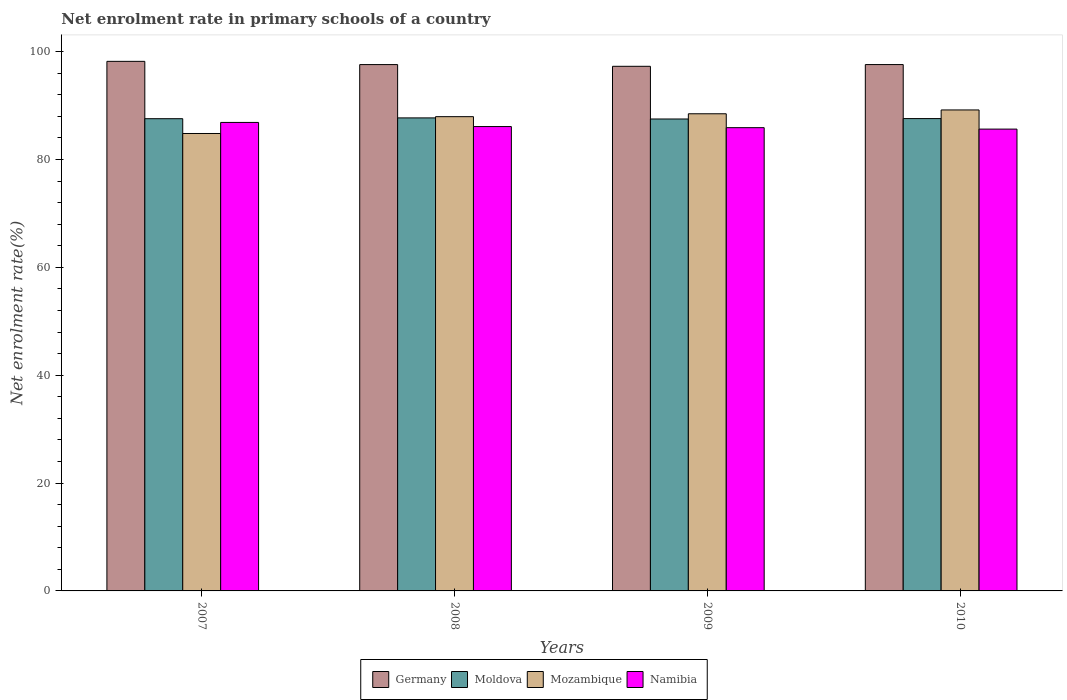How many groups of bars are there?
Provide a short and direct response. 4. Are the number of bars on each tick of the X-axis equal?
Provide a succinct answer. Yes. How many bars are there on the 2nd tick from the left?
Offer a terse response. 4. What is the label of the 1st group of bars from the left?
Give a very brief answer. 2007. What is the net enrolment rate in primary schools in Germany in 2008?
Provide a succinct answer. 97.6. Across all years, what is the maximum net enrolment rate in primary schools in Namibia?
Your answer should be compact. 86.88. Across all years, what is the minimum net enrolment rate in primary schools in Germany?
Provide a succinct answer. 97.29. In which year was the net enrolment rate in primary schools in Germany maximum?
Provide a short and direct response. 2007. In which year was the net enrolment rate in primary schools in Mozambique minimum?
Your answer should be very brief. 2007. What is the total net enrolment rate in primary schools in Mozambique in the graph?
Keep it short and to the point. 350.45. What is the difference between the net enrolment rate in primary schools in Namibia in 2008 and that in 2010?
Offer a terse response. 0.47. What is the difference between the net enrolment rate in primary schools in Namibia in 2008 and the net enrolment rate in primary schools in Mozambique in 2010?
Keep it short and to the point. -3.08. What is the average net enrolment rate in primary schools in Germany per year?
Give a very brief answer. 97.68. In the year 2009, what is the difference between the net enrolment rate in primary schools in Mozambique and net enrolment rate in primary schools in Namibia?
Provide a short and direct response. 2.57. What is the ratio of the net enrolment rate in primary schools in Moldova in 2008 to that in 2009?
Provide a short and direct response. 1. Is the difference between the net enrolment rate in primary schools in Mozambique in 2007 and 2010 greater than the difference between the net enrolment rate in primary schools in Namibia in 2007 and 2010?
Ensure brevity in your answer.  No. What is the difference between the highest and the second highest net enrolment rate in primary schools in Mozambique?
Make the answer very short. 0.71. What is the difference between the highest and the lowest net enrolment rate in primary schools in Moldova?
Keep it short and to the point. 0.2. In how many years, is the net enrolment rate in primary schools in Namibia greater than the average net enrolment rate in primary schools in Namibia taken over all years?
Provide a succinct answer. 1. Is it the case that in every year, the sum of the net enrolment rate in primary schools in Germany and net enrolment rate in primary schools in Namibia is greater than the sum of net enrolment rate in primary schools in Moldova and net enrolment rate in primary schools in Mozambique?
Provide a succinct answer. Yes. What does the 4th bar from the left in 2007 represents?
Provide a short and direct response. Namibia. What does the 2nd bar from the right in 2010 represents?
Provide a succinct answer. Mozambique. How many bars are there?
Give a very brief answer. 16. Are all the bars in the graph horizontal?
Offer a terse response. No. How many years are there in the graph?
Your answer should be compact. 4. What is the difference between two consecutive major ticks on the Y-axis?
Your response must be concise. 20. Are the values on the major ticks of Y-axis written in scientific E-notation?
Ensure brevity in your answer.  No. Does the graph contain any zero values?
Provide a short and direct response. No. Does the graph contain grids?
Offer a very short reply. No. What is the title of the graph?
Give a very brief answer. Net enrolment rate in primary schools of a country. What is the label or title of the X-axis?
Offer a very short reply. Years. What is the label or title of the Y-axis?
Offer a very short reply. Net enrolment rate(%). What is the Net enrolment rate(%) of Germany in 2007?
Your answer should be very brief. 98.2. What is the Net enrolment rate(%) of Moldova in 2007?
Provide a succinct answer. 87.57. What is the Net enrolment rate(%) in Mozambique in 2007?
Ensure brevity in your answer.  84.83. What is the Net enrolment rate(%) of Namibia in 2007?
Your answer should be compact. 86.88. What is the Net enrolment rate(%) of Germany in 2008?
Provide a succinct answer. 97.6. What is the Net enrolment rate(%) of Moldova in 2008?
Give a very brief answer. 87.72. What is the Net enrolment rate(%) in Mozambique in 2008?
Give a very brief answer. 87.95. What is the Net enrolment rate(%) of Namibia in 2008?
Provide a short and direct response. 86.11. What is the Net enrolment rate(%) of Germany in 2009?
Make the answer very short. 97.29. What is the Net enrolment rate(%) in Moldova in 2009?
Make the answer very short. 87.52. What is the Net enrolment rate(%) of Mozambique in 2009?
Offer a very short reply. 88.48. What is the Net enrolment rate(%) of Namibia in 2009?
Your answer should be very brief. 85.91. What is the Net enrolment rate(%) of Germany in 2010?
Your response must be concise. 97.61. What is the Net enrolment rate(%) in Moldova in 2010?
Keep it short and to the point. 87.59. What is the Net enrolment rate(%) of Mozambique in 2010?
Your answer should be compact. 89.19. What is the Net enrolment rate(%) in Namibia in 2010?
Provide a succinct answer. 85.64. Across all years, what is the maximum Net enrolment rate(%) of Germany?
Provide a succinct answer. 98.2. Across all years, what is the maximum Net enrolment rate(%) in Moldova?
Ensure brevity in your answer.  87.72. Across all years, what is the maximum Net enrolment rate(%) in Mozambique?
Your response must be concise. 89.19. Across all years, what is the maximum Net enrolment rate(%) in Namibia?
Provide a short and direct response. 86.88. Across all years, what is the minimum Net enrolment rate(%) in Germany?
Offer a terse response. 97.29. Across all years, what is the minimum Net enrolment rate(%) in Moldova?
Give a very brief answer. 87.52. Across all years, what is the minimum Net enrolment rate(%) in Mozambique?
Ensure brevity in your answer.  84.83. Across all years, what is the minimum Net enrolment rate(%) of Namibia?
Ensure brevity in your answer.  85.64. What is the total Net enrolment rate(%) in Germany in the graph?
Your answer should be very brief. 390.7. What is the total Net enrolment rate(%) of Moldova in the graph?
Give a very brief answer. 350.4. What is the total Net enrolment rate(%) in Mozambique in the graph?
Provide a succinct answer. 350.45. What is the total Net enrolment rate(%) in Namibia in the graph?
Ensure brevity in your answer.  344.54. What is the difference between the Net enrolment rate(%) in Germany in 2007 and that in 2008?
Your answer should be very brief. 0.6. What is the difference between the Net enrolment rate(%) of Moldova in 2007 and that in 2008?
Keep it short and to the point. -0.15. What is the difference between the Net enrolment rate(%) of Mozambique in 2007 and that in 2008?
Your response must be concise. -3.12. What is the difference between the Net enrolment rate(%) of Namibia in 2007 and that in 2008?
Make the answer very short. 0.77. What is the difference between the Net enrolment rate(%) in Germany in 2007 and that in 2009?
Keep it short and to the point. 0.92. What is the difference between the Net enrolment rate(%) in Moldova in 2007 and that in 2009?
Ensure brevity in your answer.  0.06. What is the difference between the Net enrolment rate(%) in Mozambique in 2007 and that in 2009?
Provide a short and direct response. -3.66. What is the difference between the Net enrolment rate(%) of Namibia in 2007 and that in 2009?
Your answer should be compact. 0.97. What is the difference between the Net enrolment rate(%) in Germany in 2007 and that in 2010?
Provide a succinct answer. 0.6. What is the difference between the Net enrolment rate(%) of Moldova in 2007 and that in 2010?
Your answer should be compact. -0.02. What is the difference between the Net enrolment rate(%) of Mozambique in 2007 and that in 2010?
Make the answer very short. -4.37. What is the difference between the Net enrolment rate(%) of Namibia in 2007 and that in 2010?
Make the answer very short. 1.24. What is the difference between the Net enrolment rate(%) in Germany in 2008 and that in 2009?
Give a very brief answer. 0.32. What is the difference between the Net enrolment rate(%) in Moldova in 2008 and that in 2009?
Offer a terse response. 0.2. What is the difference between the Net enrolment rate(%) of Mozambique in 2008 and that in 2009?
Offer a very short reply. -0.54. What is the difference between the Net enrolment rate(%) in Namibia in 2008 and that in 2009?
Your answer should be very brief. 0.2. What is the difference between the Net enrolment rate(%) in Germany in 2008 and that in 2010?
Keep it short and to the point. -0. What is the difference between the Net enrolment rate(%) of Moldova in 2008 and that in 2010?
Provide a succinct answer. 0.13. What is the difference between the Net enrolment rate(%) of Mozambique in 2008 and that in 2010?
Give a very brief answer. -1.25. What is the difference between the Net enrolment rate(%) of Namibia in 2008 and that in 2010?
Your answer should be very brief. 0.47. What is the difference between the Net enrolment rate(%) in Germany in 2009 and that in 2010?
Offer a terse response. -0.32. What is the difference between the Net enrolment rate(%) of Moldova in 2009 and that in 2010?
Keep it short and to the point. -0.08. What is the difference between the Net enrolment rate(%) in Mozambique in 2009 and that in 2010?
Offer a very short reply. -0.71. What is the difference between the Net enrolment rate(%) in Namibia in 2009 and that in 2010?
Your answer should be very brief. 0.27. What is the difference between the Net enrolment rate(%) of Germany in 2007 and the Net enrolment rate(%) of Moldova in 2008?
Provide a succinct answer. 10.49. What is the difference between the Net enrolment rate(%) in Germany in 2007 and the Net enrolment rate(%) in Mozambique in 2008?
Make the answer very short. 10.26. What is the difference between the Net enrolment rate(%) in Germany in 2007 and the Net enrolment rate(%) in Namibia in 2008?
Your response must be concise. 12.09. What is the difference between the Net enrolment rate(%) in Moldova in 2007 and the Net enrolment rate(%) in Mozambique in 2008?
Make the answer very short. -0.38. What is the difference between the Net enrolment rate(%) in Moldova in 2007 and the Net enrolment rate(%) in Namibia in 2008?
Your response must be concise. 1.46. What is the difference between the Net enrolment rate(%) of Mozambique in 2007 and the Net enrolment rate(%) of Namibia in 2008?
Give a very brief answer. -1.29. What is the difference between the Net enrolment rate(%) in Germany in 2007 and the Net enrolment rate(%) in Moldova in 2009?
Offer a very short reply. 10.69. What is the difference between the Net enrolment rate(%) of Germany in 2007 and the Net enrolment rate(%) of Mozambique in 2009?
Your response must be concise. 9.72. What is the difference between the Net enrolment rate(%) in Germany in 2007 and the Net enrolment rate(%) in Namibia in 2009?
Provide a short and direct response. 12.3. What is the difference between the Net enrolment rate(%) in Moldova in 2007 and the Net enrolment rate(%) in Mozambique in 2009?
Provide a succinct answer. -0.91. What is the difference between the Net enrolment rate(%) in Moldova in 2007 and the Net enrolment rate(%) in Namibia in 2009?
Provide a succinct answer. 1.66. What is the difference between the Net enrolment rate(%) of Mozambique in 2007 and the Net enrolment rate(%) of Namibia in 2009?
Your response must be concise. -1.08. What is the difference between the Net enrolment rate(%) in Germany in 2007 and the Net enrolment rate(%) in Moldova in 2010?
Your answer should be compact. 10.61. What is the difference between the Net enrolment rate(%) of Germany in 2007 and the Net enrolment rate(%) of Mozambique in 2010?
Make the answer very short. 9.01. What is the difference between the Net enrolment rate(%) in Germany in 2007 and the Net enrolment rate(%) in Namibia in 2010?
Your answer should be compact. 12.56. What is the difference between the Net enrolment rate(%) of Moldova in 2007 and the Net enrolment rate(%) of Mozambique in 2010?
Ensure brevity in your answer.  -1.62. What is the difference between the Net enrolment rate(%) of Moldova in 2007 and the Net enrolment rate(%) of Namibia in 2010?
Your answer should be very brief. 1.93. What is the difference between the Net enrolment rate(%) in Mozambique in 2007 and the Net enrolment rate(%) in Namibia in 2010?
Make the answer very short. -0.82. What is the difference between the Net enrolment rate(%) of Germany in 2008 and the Net enrolment rate(%) of Moldova in 2009?
Your response must be concise. 10.09. What is the difference between the Net enrolment rate(%) of Germany in 2008 and the Net enrolment rate(%) of Mozambique in 2009?
Offer a very short reply. 9.12. What is the difference between the Net enrolment rate(%) in Germany in 2008 and the Net enrolment rate(%) in Namibia in 2009?
Your response must be concise. 11.7. What is the difference between the Net enrolment rate(%) in Moldova in 2008 and the Net enrolment rate(%) in Mozambique in 2009?
Offer a terse response. -0.76. What is the difference between the Net enrolment rate(%) in Moldova in 2008 and the Net enrolment rate(%) in Namibia in 2009?
Ensure brevity in your answer.  1.81. What is the difference between the Net enrolment rate(%) of Mozambique in 2008 and the Net enrolment rate(%) of Namibia in 2009?
Your response must be concise. 2.04. What is the difference between the Net enrolment rate(%) of Germany in 2008 and the Net enrolment rate(%) of Moldova in 2010?
Your response must be concise. 10.01. What is the difference between the Net enrolment rate(%) of Germany in 2008 and the Net enrolment rate(%) of Mozambique in 2010?
Make the answer very short. 8.41. What is the difference between the Net enrolment rate(%) in Germany in 2008 and the Net enrolment rate(%) in Namibia in 2010?
Give a very brief answer. 11.96. What is the difference between the Net enrolment rate(%) in Moldova in 2008 and the Net enrolment rate(%) in Mozambique in 2010?
Offer a very short reply. -1.48. What is the difference between the Net enrolment rate(%) in Moldova in 2008 and the Net enrolment rate(%) in Namibia in 2010?
Offer a terse response. 2.08. What is the difference between the Net enrolment rate(%) of Mozambique in 2008 and the Net enrolment rate(%) of Namibia in 2010?
Offer a very short reply. 2.31. What is the difference between the Net enrolment rate(%) of Germany in 2009 and the Net enrolment rate(%) of Moldova in 2010?
Your answer should be compact. 9.7. What is the difference between the Net enrolment rate(%) of Germany in 2009 and the Net enrolment rate(%) of Mozambique in 2010?
Your answer should be compact. 8.09. What is the difference between the Net enrolment rate(%) of Germany in 2009 and the Net enrolment rate(%) of Namibia in 2010?
Your answer should be very brief. 11.65. What is the difference between the Net enrolment rate(%) in Moldova in 2009 and the Net enrolment rate(%) in Mozambique in 2010?
Make the answer very short. -1.68. What is the difference between the Net enrolment rate(%) in Moldova in 2009 and the Net enrolment rate(%) in Namibia in 2010?
Keep it short and to the point. 1.87. What is the difference between the Net enrolment rate(%) of Mozambique in 2009 and the Net enrolment rate(%) of Namibia in 2010?
Provide a succinct answer. 2.84. What is the average Net enrolment rate(%) of Germany per year?
Provide a short and direct response. 97.68. What is the average Net enrolment rate(%) of Moldova per year?
Your response must be concise. 87.6. What is the average Net enrolment rate(%) of Mozambique per year?
Your answer should be compact. 87.61. What is the average Net enrolment rate(%) of Namibia per year?
Offer a terse response. 86.13. In the year 2007, what is the difference between the Net enrolment rate(%) in Germany and Net enrolment rate(%) in Moldova?
Provide a short and direct response. 10.63. In the year 2007, what is the difference between the Net enrolment rate(%) of Germany and Net enrolment rate(%) of Mozambique?
Your answer should be compact. 13.38. In the year 2007, what is the difference between the Net enrolment rate(%) of Germany and Net enrolment rate(%) of Namibia?
Provide a short and direct response. 11.33. In the year 2007, what is the difference between the Net enrolment rate(%) in Moldova and Net enrolment rate(%) in Mozambique?
Provide a short and direct response. 2.75. In the year 2007, what is the difference between the Net enrolment rate(%) of Moldova and Net enrolment rate(%) of Namibia?
Make the answer very short. 0.69. In the year 2007, what is the difference between the Net enrolment rate(%) in Mozambique and Net enrolment rate(%) in Namibia?
Give a very brief answer. -2.05. In the year 2008, what is the difference between the Net enrolment rate(%) of Germany and Net enrolment rate(%) of Moldova?
Keep it short and to the point. 9.89. In the year 2008, what is the difference between the Net enrolment rate(%) of Germany and Net enrolment rate(%) of Mozambique?
Provide a short and direct response. 9.66. In the year 2008, what is the difference between the Net enrolment rate(%) of Germany and Net enrolment rate(%) of Namibia?
Provide a short and direct response. 11.49. In the year 2008, what is the difference between the Net enrolment rate(%) of Moldova and Net enrolment rate(%) of Mozambique?
Ensure brevity in your answer.  -0.23. In the year 2008, what is the difference between the Net enrolment rate(%) in Moldova and Net enrolment rate(%) in Namibia?
Offer a very short reply. 1.61. In the year 2008, what is the difference between the Net enrolment rate(%) in Mozambique and Net enrolment rate(%) in Namibia?
Your answer should be very brief. 1.83. In the year 2009, what is the difference between the Net enrolment rate(%) in Germany and Net enrolment rate(%) in Moldova?
Keep it short and to the point. 9.77. In the year 2009, what is the difference between the Net enrolment rate(%) of Germany and Net enrolment rate(%) of Mozambique?
Ensure brevity in your answer.  8.8. In the year 2009, what is the difference between the Net enrolment rate(%) of Germany and Net enrolment rate(%) of Namibia?
Your response must be concise. 11.38. In the year 2009, what is the difference between the Net enrolment rate(%) in Moldova and Net enrolment rate(%) in Mozambique?
Provide a succinct answer. -0.97. In the year 2009, what is the difference between the Net enrolment rate(%) in Moldova and Net enrolment rate(%) in Namibia?
Your answer should be very brief. 1.61. In the year 2009, what is the difference between the Net enrolment rate(%) of Mozambique and Net enrolment rate(%) of Namibia?
Give a very brief answer. 2.58. In the year 2010, what is the difference between the Net enrolment rate(%) of Germany and Net enrolment rate(%) of Moldova?
Your response must be concise. 10.02. In the year 2010, what is the difference between the Net enrolment rate(%) in Germany and Net enrolment rate(%) in Mozambique?
Your answer should be compact. 8.41. In the year 2010, what is the difference between the Net enrolment rate(%) in Germany and Net enrolment rate(%) in Namibia?
Give a very brief answer. 11.97. In the year 2010, what is the difference between the Net enrolment rate(%) of Moldova and Net enrolment rate(%) of Mozambique?
Your answer should be very brief. -1.6. In the year 2010, what is the difference between the Net enrolment rate(%) in Moldova and Net enrolment rate(%) in Namibia?
Provide a short and direct response. 1.95. In the year 2010, what is the difference between the Net enrolment rate(%) of Mozambique and Net enrolment rate(%) of Namibia?
Provide a succinct answer. 3.55. What is the ratio of the Net enrolment rate(%) of Moldova in 2007 to that in 2008?
Provide a short and direct response. 1. What is the ratio of the Net enrolment rate(%) of Mozambique in 2007 to that in 2008?
Offer a very short reply. 0.96. What is the ratio of the Net enrolment rate(%) in Namibia in 2007 to that in 2008?
Keep it short and to the point. 1.01. What is the ratio of the Net enrolment rate(%) of Germany in 2007 to that in 2009?
Provide a succinct answer. 1.01. What is the ratio of the Net enrolment rate(%) in Moldova in 2007 to that in 2009?
Make the answer very short. 1. What is the ratio of the Net enrolment rate(%) of Mozambique in 2007 to that in 2009?
Provide a short and direct response. 0.96. What is the ratio of the Net enrolment rate(%) in Namibia in 2007 to that in 2009?
Make the answer very short. 1.01. What is the ratio of the Net enrolment rate(%) in Germany in 2007 to that in 2010?
Keep it short and to the point. 1.01. What is the ratio of the Net enrolment rate(%) of Moldova in 2007 to that in 2010?
Provide a short and direct response. 1. What is the ratio of the Net enrolment rate(%) of Mozambique in 2007 to that in 2010?
Keep it short and to the point. 0.95. What is the ratio of the Net enrolment rate(%) in Namibia in 2007 to that in 2010?
Your response must be concise. 1.01. What is the ratio of the Net enrolment rate(%) of Germany in 2008 to that in 2009?
Give a very brief answer. 1. What is the ratio of the Net enrolment rate(%) in Mozambique in 2008 to that in 2009?
Your answer should be compact. 0.99. What is the ratio of the Net enrolment rate(%) of Germany in 2008 to that in 2010?
Give a very brief answer. 1. What is the ratio of the Net enrolment rate(%) of Moldova in 2008 to that in 2010?
Your answer should be very brief. 1. What is the ratio of the Net enrolment rate(%) of Mozambique in 2008 to that in 2010?
Offer a terse response. 0.99. What is the ratio of the Net enrolment rate(%) in Namibia in 2008 to that in 2010?
Your answer should be compact. 1.01. What is the ratio of the Net enrolment rate(%) in Germany in 2009 to that in 2010?
Offer a terse response. 1. What is the ratio of the Net enrolment rate(%) of Moldova in 2009 to that in 2010?
Your answer should be compact. 1. What is the ratio of the Net enrolment rate(%) of Namibia in 2009 to that in 2010?
Your answer should be compact. 1. What is the difference between the highest and the second highest Net enrolment rate(%) of Germany?
Your answer should be compact. 0.6. What is the difference between the highest and the second highest Net enrolment rate(%) in Moldova?
Make the answer very short. 0.13. What is the difference between the highest and the second highest Net enrolment rate(%) of Mozambique?
Ensure brevity in your answer.  0.71. What is the difference between the highest and the second highest Net enrolment rate(%) of Namibia?
Your answer should be compact. 0.77. What is the difference between the highest and the lowest Net enrolment rate(%) of Germany?
Offer a very short reply. 0.92. What is the difference between the highest and the lowest Net enrolment rate(%) of Moldova?
Offer a very short reply. 0.2. What is the difference between the highest and the lowest Net enrolment rate(%) in Mozambique?
Keep it short and to the point. 4.37. What is the difference between the highest and the lowest Net enrolment rate(%) of Namibia?
Offer a terse response. 1.24. 